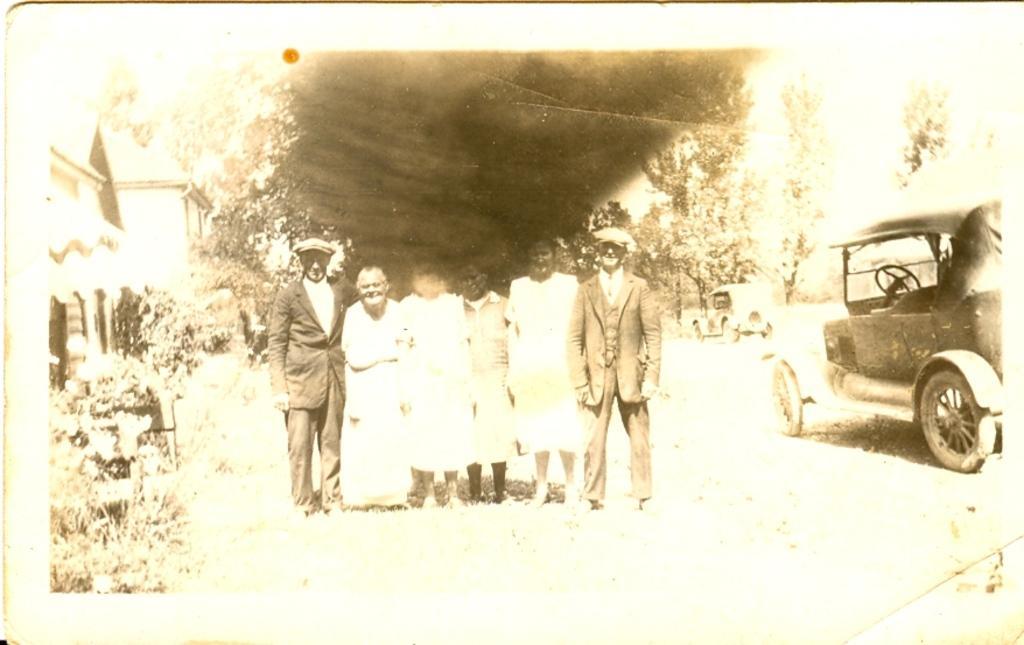Please provide a concise description of this image. In this image we can see an old picture, there are vehicle, people, plants, a house, and some trees in the picture. 